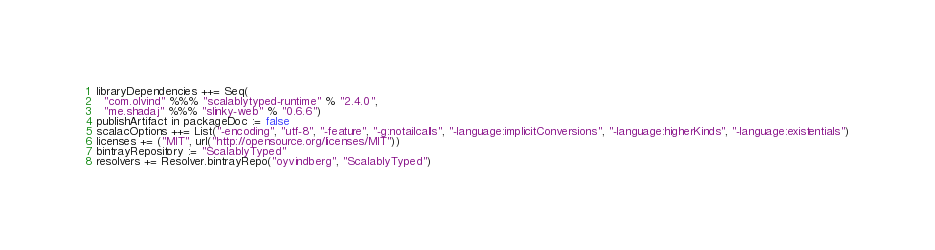Convert code to text. <code><loc_0><loc_0><loc_500><loc_500><_Scala_>libraryDependencies ++= Seq(
  "com.olvind" %%% "scalablytyped-runtime" % "2.4.0",
  "me.shadaj" %%% "slinky-web" % "0.6.6")
publishArtifact in packageDoc := false
scalacOptions ++= List("-encoding", "utf-8", "-feature", "-g:notailcalls", "-language:implicitConversions", "-language:higherKinds", "-language:existentials")
licenses += ("MIT", url("http://opensource.org/licenses/MIT"))
bintrayRepository := "ScalablyTyped"
resolvers += Resolver.bintrayRepo("oyvindberg", "ScalablyTyped")
</code> 